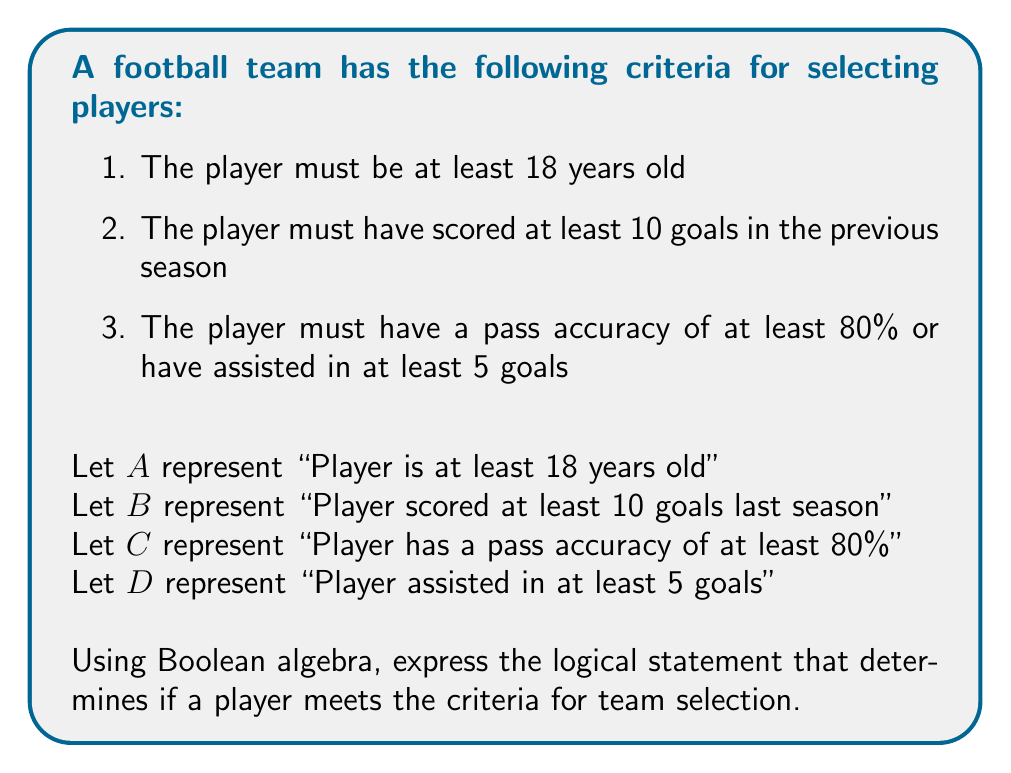Give your solution to this math problem. To solve this problem, we need to combine the given criteria using logical operators. Let's break it down step-by-step:

1. The player must meet all three main criteria, so we'll use the AND operator ($\land$) to connect them.

2. The first two criteria are straightforward:
   - $A$: Player is at least 18 years old
   - $B$: Player scored at least 10 goals last season

3. The third criterion is a combination of two conditions, where the player must meet at least one of them. We'll use the OR operator ($\lor$) to connect these:
   - $C \lor D$: Player has a pass accuracy of at least 80% OR assisted in at least 5 goals

4. Now, we can combine all these conditions using the AND operator:

   $A \land B \land (C \lor D)$

This Boolean expression represents the logical statement that determines if a player meets all the criteria for team selection.
Answer: $A \land B \land (C \lor D)$ 